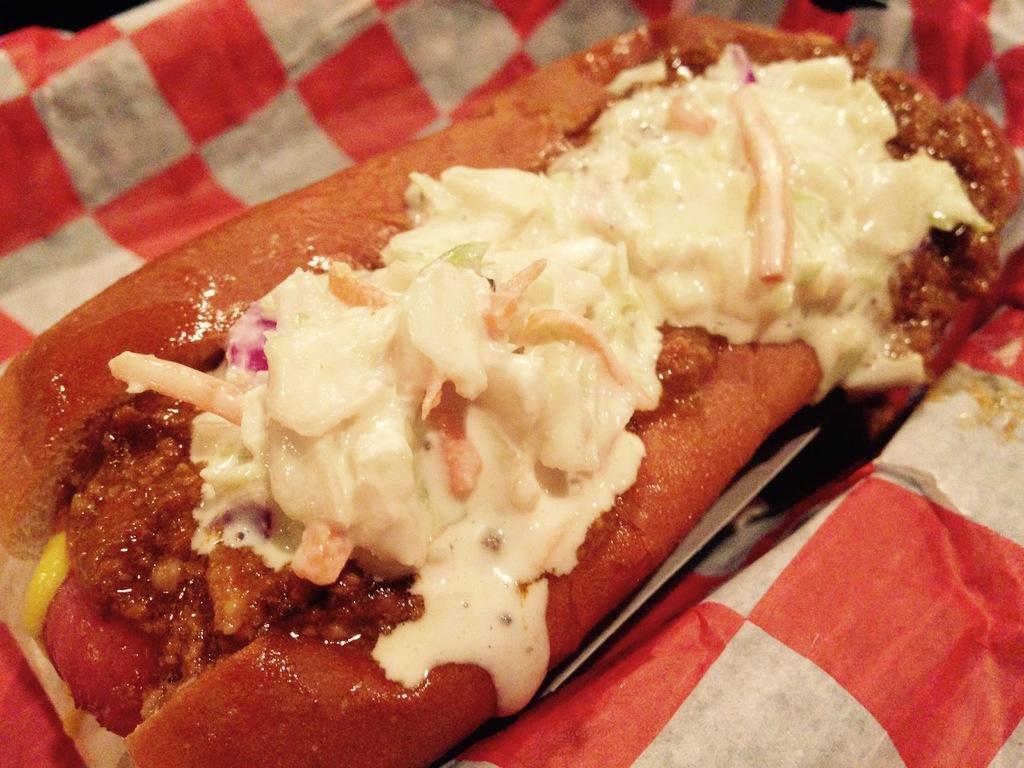Can you describe this image briefly? In this picture we can see some food items on the paper. 